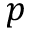Convert formula to latex. <formula><loc_0><loc_0><loc_500><loc_500>p</formula> 